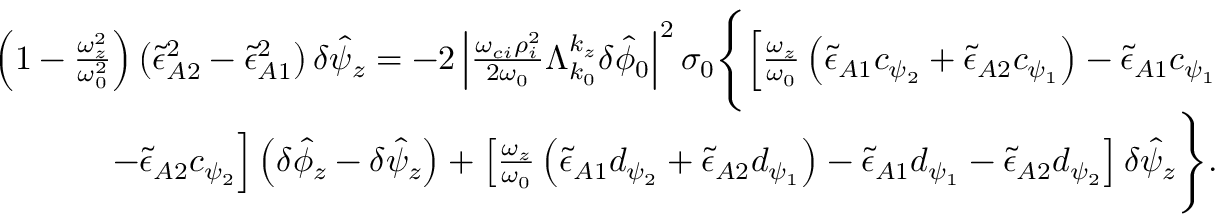<formula> <loc_0><loc_0><loc_500><loc_500>\begin{array} { r } { \left ( 1 - \frac { \omega _ { z } ^ { 2 } } { \omega _ { 0 } ^ { 2 } } \right ) \left ( \tilde { \epsilon } _ { A 2 } ^ { 2 } - \tilde { \epsilon } _ { A 1 } ^ { 2 } \right ) \delta \hat { \psi } _ { z } = - 2 \left | \frac { \omega _ { c i } \rho _ { i } ^ { 2 } } { 2 \omega _ { 0 } } \Lambda _ { k _ { 0 } } ^ { k _ { z } } \delta \hat { \phi } _ { 0 } \right | ^ { 2 } \sigma _ { 0 } \left \{ \left [ \frac { \omega _ { z } } { \omega _ { 0 } } \left ( \tilde { \epsilon } _ { A 1 } c _ { \psi _ { 2 } } + \tilde { \epsilon } _ { A 2 } c _ { \psi _ { 1 } } \right ) - \tilde { \epsilon } _ { A 1 } c _ { \psi _ { 1 } } } \\ { - \tilde { \epsilon } _ { A 2 } c _ { \psi _ { 2 } } \right ] \left ( \delta \hat { \phi } _ { z } - \delta \hat { \psi } _ { z } \right ) + \left [ \frac { \omega _ { z } } { \omega _ { 0 } } \left ( \tilde { \epsilon } _ { A 1 } d _ { \psi _ { 2 } } + \tilde { \epsilon } _ { A 2 } d _ { \psi _ { 1 } } \right ) - \tilde { \epsilon } _ { A 1 } d _ { \psi _ { 1 } } - \tilde { \epsilon } _ { A 2 } d _ { \psi _ { 2 } } \right ] \delta \hat { \psi } _ { z } \right \} . } \end{array}</formula> 